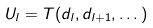<formula> <loc_0><loc_0><loc_500><loc_500>U _ { l } = T ( d _ { l } , d _ { l + 1 } , \dots )</formula> 